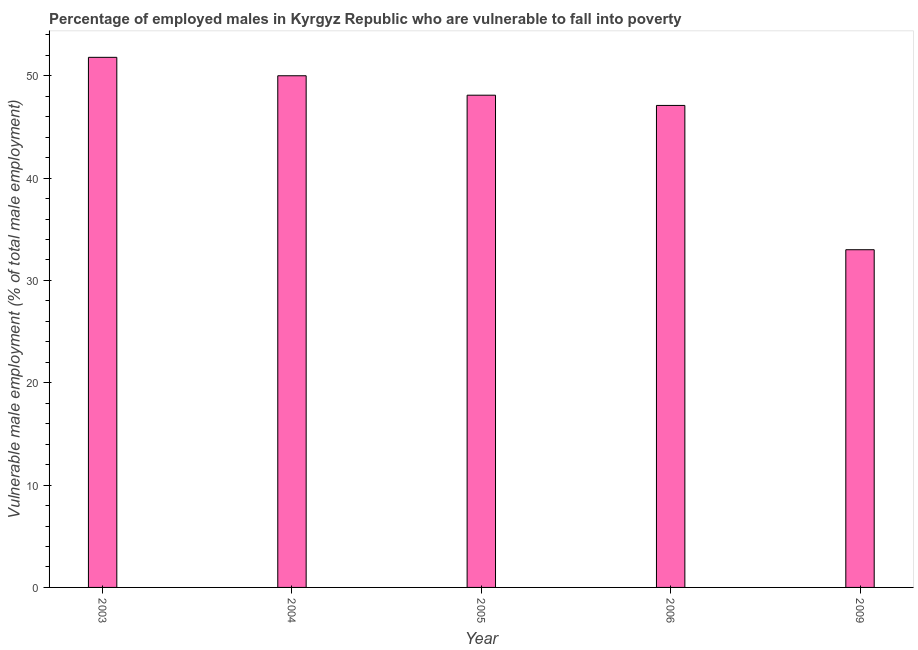Does the graph contain any zero values?
Your answer should be very brief. No. What is the title of the graph?
Make the answer very short. Percentage of employed males in Kyrgyz Republic who are vulnerable to fall into poverty. What is the label or title of the X-axis?
Provide a short and direct response. Year. What is the label or title of the Y-axis?
Provide a short and direct response. Vulnerable male employment (% of total male employment). What is the percentage of employed males who are vulnerable to fall into poverty in 2006?
Give a very brief answer. 47.1. Across all years, what is the maximum percentage of employed males who are vulnerable to fall into poverty?
Offer a terse response. 51.8. Across all years, what is the minimum percentage of employed males who are vulnerable to fall into poverty?
Your response must be concise. 33. What is the sum of the percentage of employed males who are vulnerable to fall into poverty?
Your answer should be compact. 230. What is the difference between the percentage of employed males who are vulnerable to fall into poverty in 2003 and 2005?
Offer a very short reply. 3.7. What is the average percentage of employed males who are vulnerable to fall into poverty per year?
Your response must be concise. 46. What is the median percentage of employed males who are vulnerable to fall into poverty?
Keep it short and to the point. 48.1. Do a majority of the years between 2009 and 2005 (inclusive) have percentage of employed males who are vulnerable to fall into poverty greater than 28 %?
Give a very brief answer. Yes. What is the ratio of the percentage of employed males who are vulnerable to fall into poverty in 2004 to that in 2005?
Your answer should be compact. 1.04. Is the percentage of employed males who are vulnerable to fall into poverty in 2004 less than that in 2005?
Your answer should be compact. No. Is the difference between the percentage of employed males who are vulnerable to fall into poverty in 2005 and 2006 greater than the difference between any two years?
Keep it short and to the point. No. Is the sum of the percentage of employed males who are vulnerable to fall into poverty in 2003 and 2009 greater than the maximum percentage of employed males who are vulnerable to fall into poverty across all years?
Ensure brevity in your answer.  Yes. What is the difference between the highest and the lowest percentage of employed males who are vulnerable to fall into poverty?
Ensure brevity in your answer.  18.8. In how many years, is the percentage of employed males who are vulnerable to fall into poverty greater than the average percentage of employed males who are vulnerable to fall into poverty taken over all years?
Keep it short and to the point. 4. How many bars are there?
Offer a very short reply. 5. Are all the bars in the graph horizontal?
Offer a terse response. No. What is the difference between two consecutive major ticks on the Y-axis?
Provide a succinct answer. 10. Are the values on the major ticks of Y-axis written in scientific E-notation?
Make the answer very short. No. What is the Vulnerable male employment (% of total male employment) of 2003?
Offer a very short reply. 51.8. What is the Vulnerable male employment (% of total male employment) in 2005?
Give a very brief answer. 48.1. What is the Vulnerable male employment (% of total male employment) of 2006?
Make the answer very short. 47.1. What is the difference between the Vulnerable male employment (% of total male employment) in 2003 and 2005?
Give a very brief answer. 3.7. What is the difference between the Vulnerable male employment (% of total male employment) in 2003 and 2009?
Give a very brief answer. 18.8. What is the difference between the Vulnerable male employment (% of total male employment) in 2004 and 2005?
Provide a succinct answer. 1.9. What is the difference between the Vulnerable male employment (% of total male employment) in 2004 and 2006?
Give a very brief answer. 2.9. What is the difference between the Vulnerable male employment (% of total male employment) in 2005 and 2006?
Make the answer very short. 1. What is the difference between the Vulnerable male employment (% of total male employment) in 2005 and 2009?
Your response must be concise. 15.1. What is the ratio of the Vulnerable male employment (% of total male employment) in 2003 to that in 2004?
Your answer should be compact. 1.04. What is the ratio of the Vulnerable male employment (% of total male employment) in 2003 to that in 2005?
Provide a succinct answer. 1.08. What is the ratio of the Vulnerable male employment (% of total male employment) in 2003 to that in 2006?
Your answer should be compact. 1.1. What is the ratio of the Vulnerable male employment (% of total male employment) in 2003 to that in 2009?
Provide a succinct answer. 1.57. What is the ratio of the Vulnerable male employment (% of total male employment) in 2004 to that in 2005?
Provide a succinct answer. 1.04. What is the ratio of the Vulnerable male employment (% of total male employment) in 2004 to that in 2006?
Give a very brief answer. 1.06. What is the ratio of the Vulnerable male employment (% of total male employment) in 2004 to that in 2009?
Your response must be concise. 1.51. What is the ratio of the Vulnerable male employment (% of total male employment) in 2005 to that in 2009?
Offer a very short reply. 1.46. What is the ratio of the Vulnerable male employment (% of total male employment) in 2006 to that in 2009?
Offer a terse response. 1.43. 